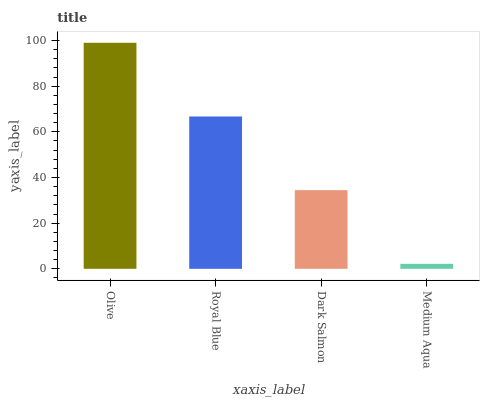Is Medium Aqua the minimum?
Answer yes or no. Yes. Is Olive the maximum?
Answer yes or no. Yes. Is Royal Blue the minimum?
Answer yes or no. No. Is Royal Blue the maximum?
Answer yes or no. No. Is Olive greater than Royal Blue?
Answer yes or no. Yes. Is Royal Blue less than Olive?
Answer yes or no. Yes. Is Royal Blue greater than Olive?
Answer yes or no. No. Is Olive less than Royal Blue?
Answer yes or no. No. Is Royal Blue the high median?
Answer yes or no. Yes. Is Dark Salmon the low median?
Answer yes or no. Yes. Is Medium Aqua the high median?
Answer yes or no. No. Is Royal Blue the low median?
Answer yes or no. No. 